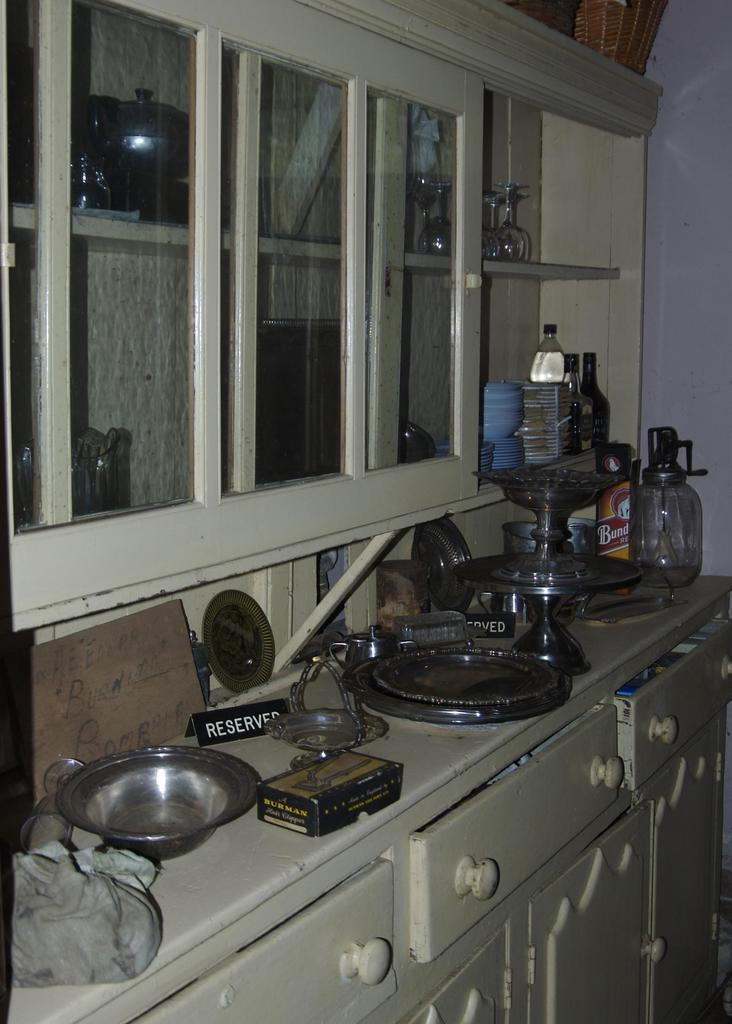<image>
Present a compact description of the photo's key features. A kitchen with several appliances and bottles of cleaning materials with a reserved sign on the middle. 